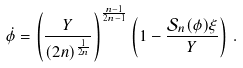<formula> <loc_0><loc_0><loc_500><loc_500>\dot { \phi } = \left ( \frac { Y } { ( 2 n ) ^ { \frac { 1 } { 2 n } } } \right ) ^ { \frac { n - 1 } { 2 n - 1 } } \left ( 1 - \frac { { \mathcal { S } } _ { n } ( \phi ) \xi } { Y } \right ) \, .</formula> 